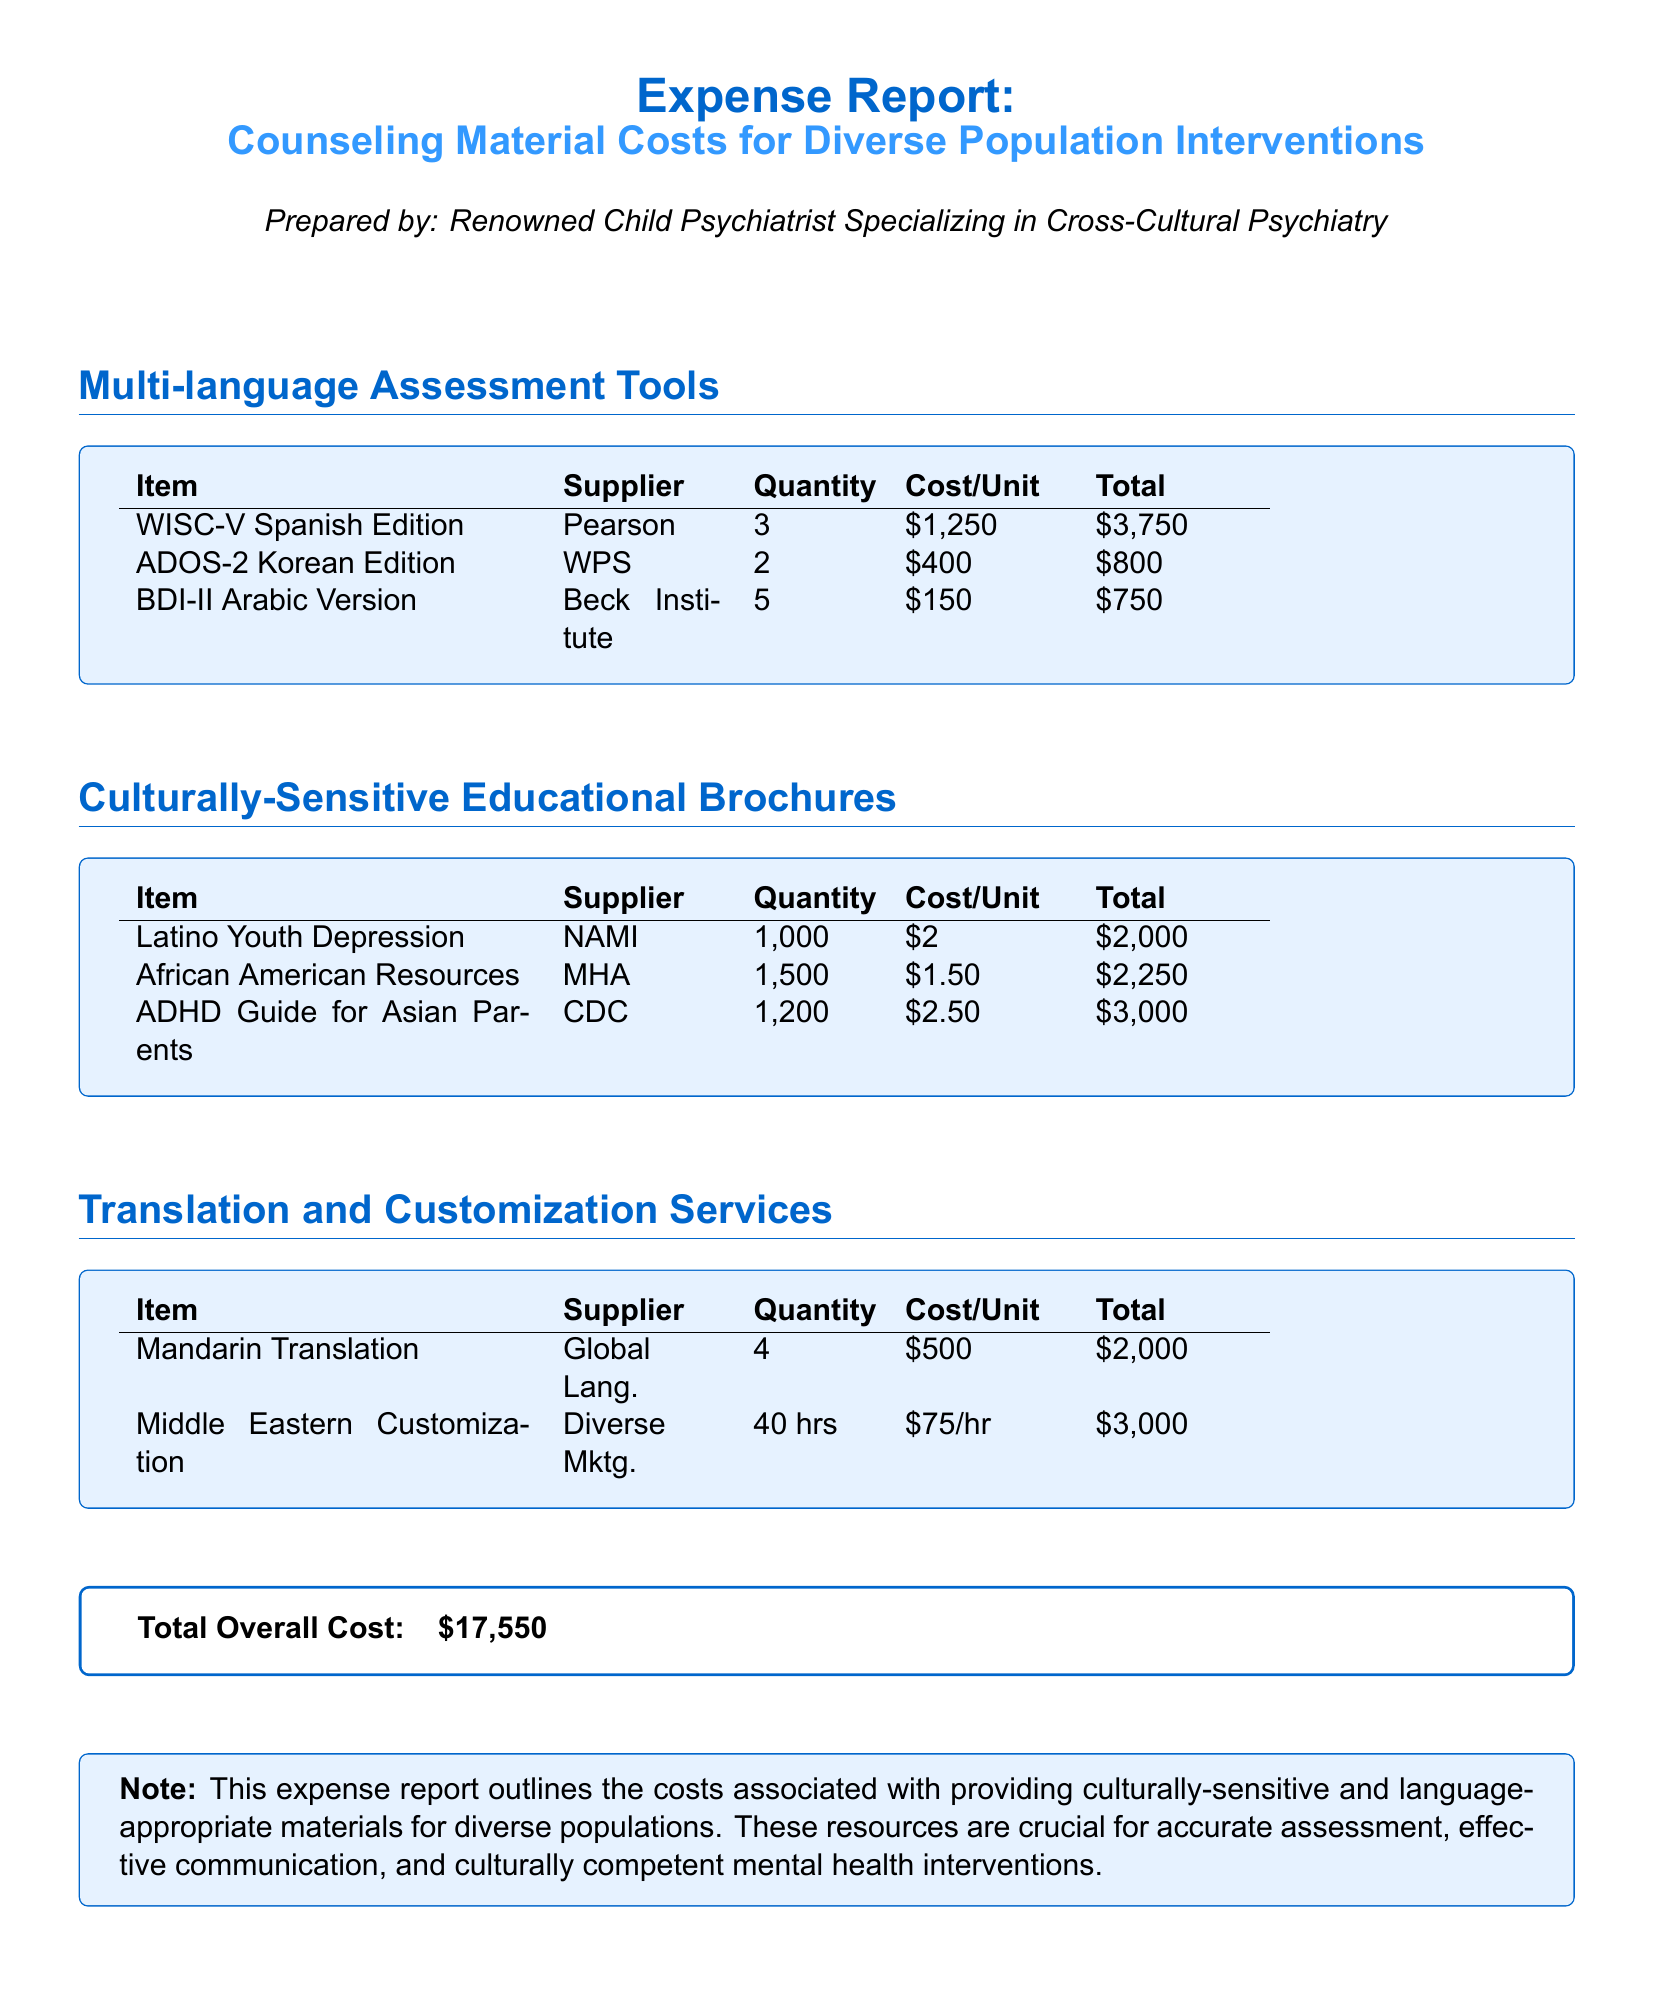What is the total cost of multi-language assessment tools? The total cost is found by adding the total costs of the items in the section, which is $3,750 + $800 + $750 = $5,300.
Answer: $5,300 How many ADHD Guides for Asian Parents were ordered? The quantity of ADHD Guides for Asian Parents is listed in the educational brochures section as 1,200.
Answer: 1,200 What is the cost per unit of the BDI-II Arabic Version? The cost per unit for the BDI-II Arabic Version is specified as $150 in the multi-language assessment tools section.
Answer: $150 Which supplier provided the Latino Youth Depression brochure? The supplier for the Latino Youth Depression brochure is listed as NAMI.
Answer: NAMI How many hours were dedicated to Middle Eastern customization services? The document states that 40 hours were allocated for Middle Eastern customization services.
Answer: 40 hrs What is the total overall cost outlined in the report? The total overall cost is given at the end of the document as $17,550.
Answer: $17,550 What type of document is this? This document is an expense report focusing on counseling material costs for diverse population interventions.
Answer: Expense report Which multi-language assessment tool had the highest total cost? The WISC-V Spanish Edition incurred the highest total cost, which is $3,750.
Answer: WISC-V Spanish Edition What was the quantity of African American Resources ordered? The quantity listed for African American Resources is 1,500.
Answer: 1,500 